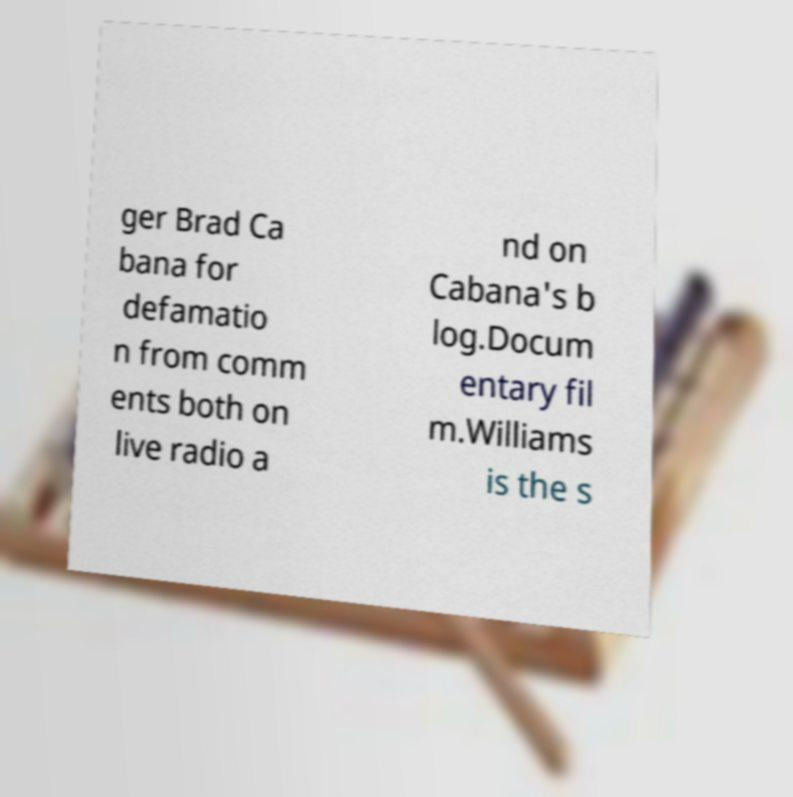For documentation purposes, I need the text within this image transcribed. Could you provide that? ger Brad Ca bana for defamatio n from comm ents both on live radio a nd on Cabana's b log.Docum entary fil m.Williams is the s 